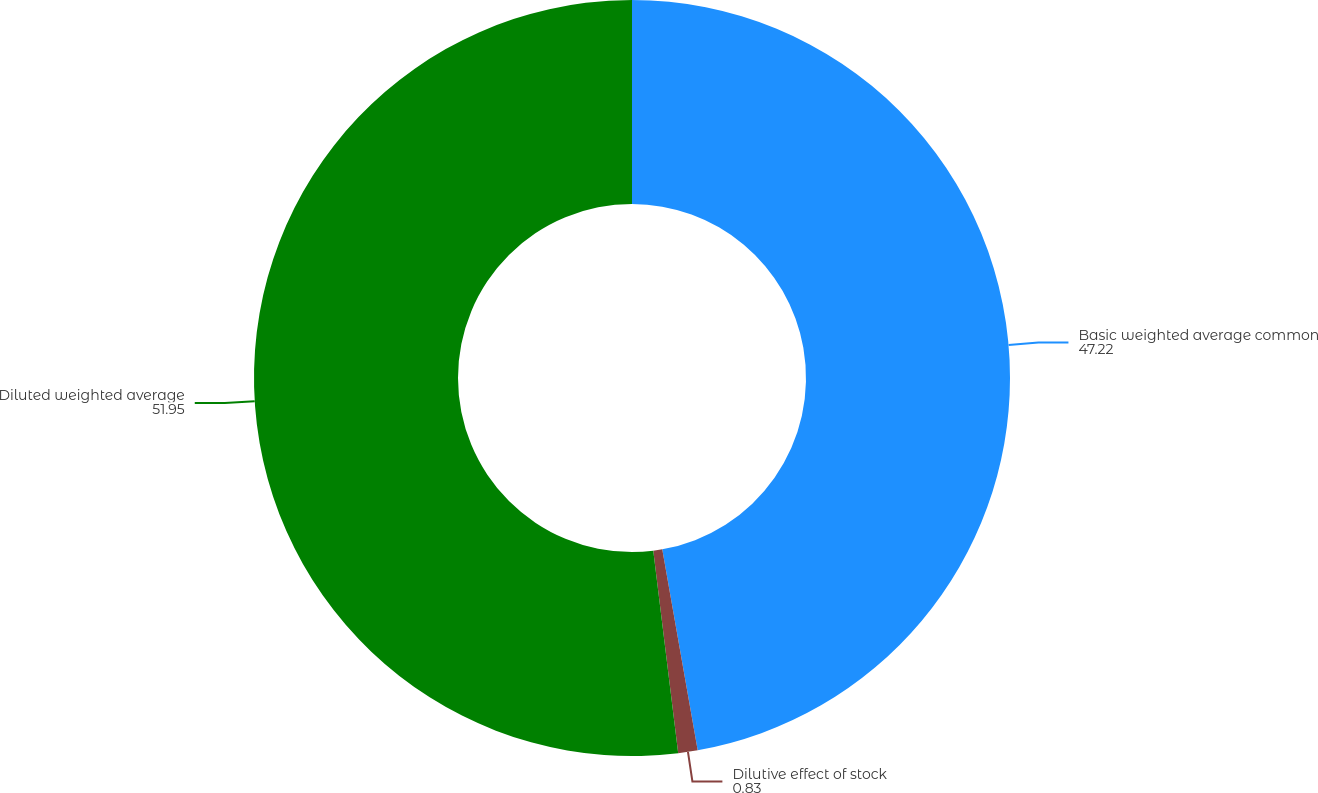Convert chart to OTSL. <chart><loc_0><loc_0><loc_500><loc_500><pie_chart><fcel>Basic weighted average common<fcel>Dilutive effect of stock<fcel>Diluted weighted average<nl><fcel>47.22%<fcel>0.83%<fcel>51.95%<nl></chart> 